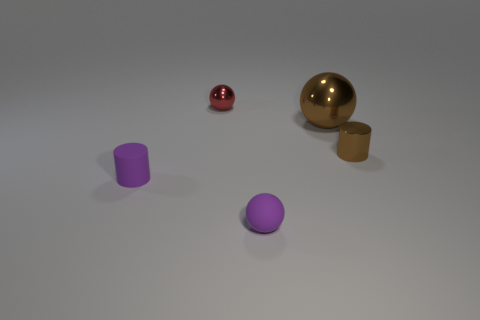There is a small metallic object behind the small brown metal cylinder; what is its shape?
Keep it short and to the point. Sphere. There is a ball that is on the right side of the rubber thing right of the red object; what color is it?
Keep it short and to the point. Brown. What number of objects are tiny cylinders that are left of the large brown shiny ball or tiny red metal spheres?
Keep it short and to the point. 2. Is the size of the red shiny object the same as the matte thing that is left of the tiny red thing?
Make the answer very short. Yes. What number of tiny objects are either brown metallic things or purple rubber blocks?
Your answer should be compact. 1. The small red thing has what shape?
Ensure brevity in your answer.  Sphere. What size is the shiny thing that is the same color as the big metallic ball?
Your answer should be compact. Small. Is there another large sphere made of the same material as the brown ball?
Give a very brief answer. No. Is the number of tiny red rubber objects greater than the number of big shiny objects?
Your answer should be very brief. No. Do the tiny red sphere and the tiny brown cylinder have the same material?
Your answer should be compact. Yes. 